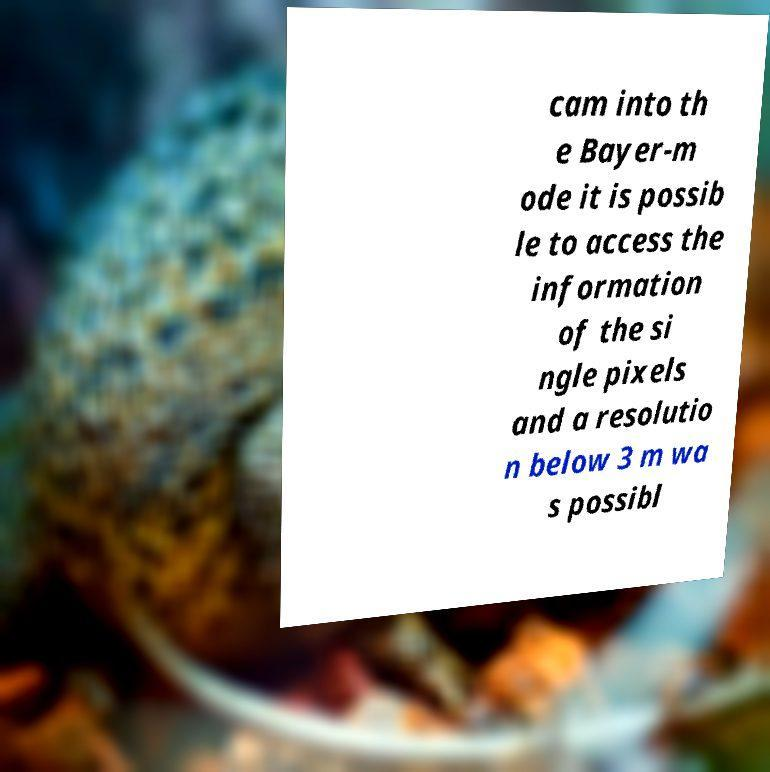Can you accurately transcribe the text from the provided image for me? cam into th e Bayer-m ode it is possib le to access the information of the si ngle pixels and a resolutio n below 3 m wa s possibl 